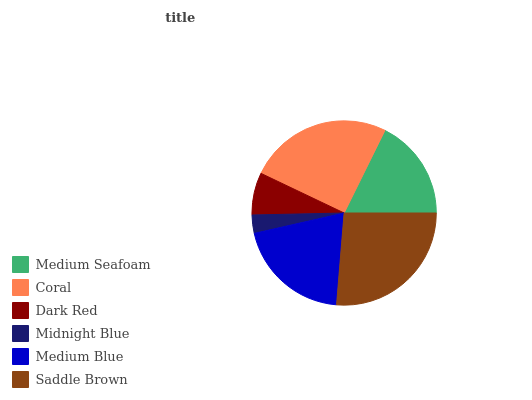Is Midnight Blue the minimum?
Answer yes or no. Yes. Is Saddle Brown the maximum?
Answer yes or no. Yes. Is Coral the minimum?
Answer yes or no. No. Is Coral the maximum?
Answer yes or no. No. Is Coral greater than Medium Seafoam?
Answer yes or no. Yes. Is Medium Seafoam less than Coral?
Answer yes or no. Yes. Is Medium Seafoam greater than Coral?
Answer yes or no. No. Is Coral less than Medium Seafoam?
Answer yes or no. No. Is Medium Blue the high median?
Answer yes or no. Yes. Is Medium Seafoam the low median?
Answer yes or no. Yes. Is Midnight Blue the high median?
Answer yes or no. No. Is Medium Blue the low median?
Answer yes or no. No. 